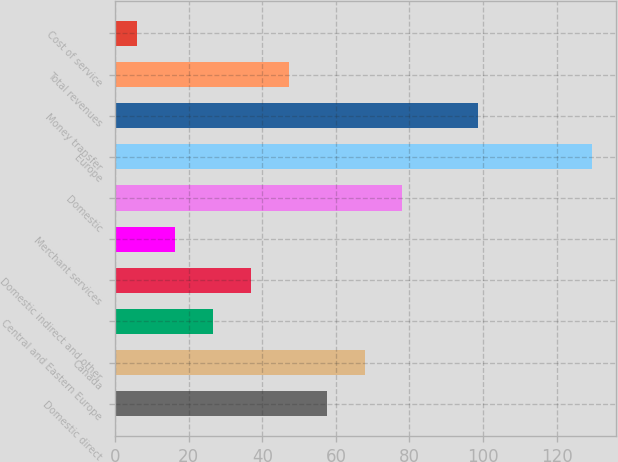<chart> <loc_0><loc_0><loc_500><loc_500><bar_chart><fcel>Domestic direct<fcel>Canada<fcel>Central and Eastern Europe<fcel>Domestic indirect and other<fcel>Merchant services<fcel>Domestic<fcel>Europe<fcel>Money transfer<fcel>Total revenues<fcel>Cost of service<nl><fcel>57.5<fcel>67.8<fcel>26.6<fcel>36.9<fcel>16.3<fcel>78.1<fcel>129.6<fcel>98.7<fcel>47.2<fcel>6<nl></chart> 